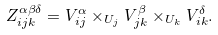Convert formula to latex. <formula><loc_0><loc_0><loc_500><loc_500>Z _ { i j k } ^ { \alpha \beta \delta } = V _ { i j } ^ { \alpha } \times _ { U _ { j } } V _ { j k } ^ { \beta } \times _ { U _ { k } } V _ { i k } ^ { \delta } .</formula> 